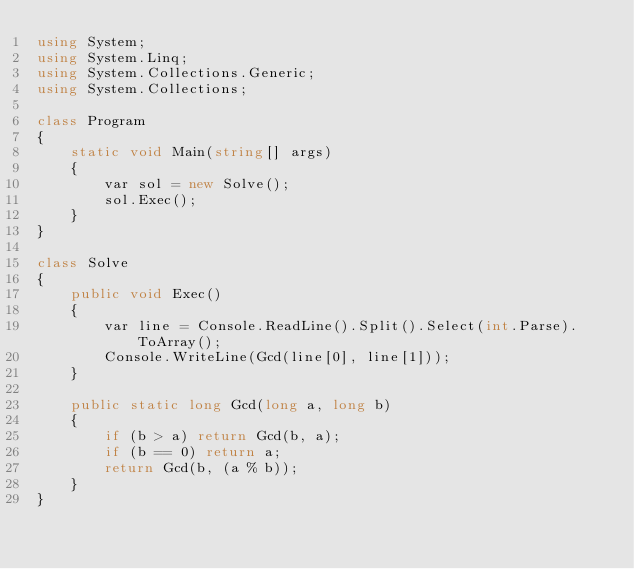<code> <loc_0><loc_0><loc_500><loc_500><_C#_>using System;
using System.Linq;
using System.Collections.Generic;
using System.Collections;

class Program
{
    static void Main(string[] args)
    {
        var sol = new Solve();
        sol.Exec();
    }
}

class Solve
{
    public void Exec()
    {
        var line = Console.ReadLine().Split().Select(int.Parse).ToArray();
        Console.WriteLine(Gcd(line[0], line[1]));
    }

    public static long Gcd(long a, long b)
    {
        if (b > a) return Gcd(b, a);
        if (b == 0) return a;
        return Gcd(b, (a % b));
    }
}

</code> 